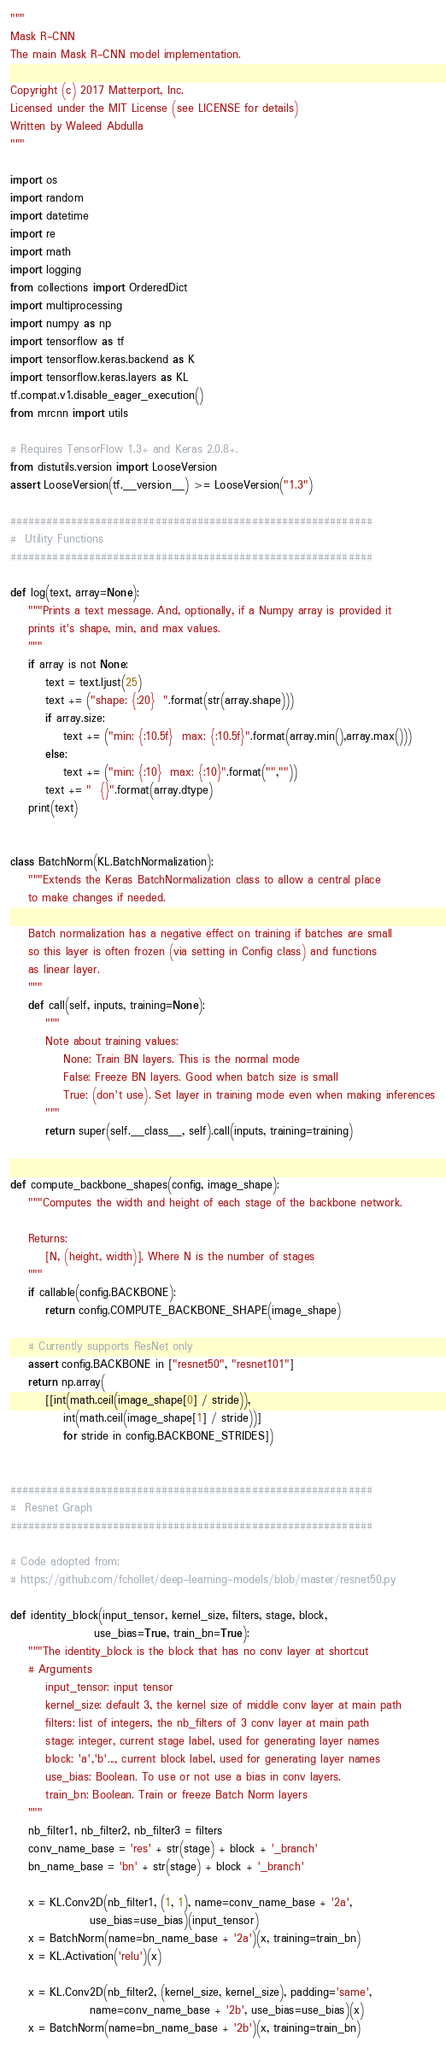Convert code to text. <code><loc_0><loc_0><loc_500><loc_500><_Python_>"""
Mask R-CNN
The main Mask R-CNN model implementation.

Copyright (c) 2017 Matterport, Inc.
Licensed under the MIT License (see LICENSE for details)
Written by Waleed Abdulla
"""

import os
import random
import datetime
import re
import math
import logging
from collections import OrderedDict
import multiprocessing
import numpy as np
import tensorflow as tf
import tensorflow.keras.backend as K
import tensorflow.keras.layers as KL
tf.compat.v1.disable_eager_execution()
from mrcnn import utils

# Requires TensorFlow 1.3+ and Keras 2.0.8+.
from distutils.version import LooseVersion
assert LooseVersion(tf.__version__) >= LooseVersion("1.3")

############################################################
#  Utility Functions
############################################################

def log(text, array=None):
    """Prints a text message. And, optionally, if a Numpy array is provided it
    prints it's shape, min, and max values.
    """
    if array is not None:
        text = text.ljust(25)
        text += ("shape: {:20}  ".format(str(array.shape)))
        if array.size:
            text += ("min: {:10.5f}  max: {:10.5f}".format(array.min(),array.max()))
        else:
            text += ("min: {:10}  max: {:10}".format("",""))
        text += "  {}".format(array.dtype)
    print(text)


class BatchNorm(KL.BatchNormalization):
    """Extends the Keras BatchNormalization class to allow a central place
    to make changes if needed.

    Batch normalization has a negative effect on training if batches are small
    so this layer is often frozen (via setting in Config class) and functions
    as linear layer.
    """
    def call(self, inputs, training=None):
        """
        Note about training values:
            None: Train BN layers. This is the normal mode
            False: Freeze BN layers. Good when batch size is small
            True: (don't use). Set layer in training mode even when making inferences
        """
        return super(self.__class__, self).call(inputs, training=training)


def compute_backbone_shapes(config, image_shape):
    """Computes the width and height of each stage of the backbone network.

    Returns:
        [N, (height, width)]. Where N is the number of stages
    """
    if callable(config.BACKBONE):
        return config.COMPUTE_BACKBONE_SHAPE(image_shape)

    # Currently supports ResNet only
    assert config.BACKBONE in ["resnet50", "resnet101"]
    return np.array(
        [[int(math.ceil(image_shape[0] / stride)),
            int(math.ceil(image_shape[1] / stride))]
            for stride in config.BACKBONE_STRIDES])


############################################################
#  Resnet Graph
############################################################

# Code adopted from:
# https://github.com/fchollet/deep-learning-models/blob/master/resnet50.py

def identity_block(input_tensor, kernel_size, filters, stage, block,
                   use_bias=True, train_bn=True):
    """The identity_block is the block that has no conv layer at shortcut
    # Arguments
        input_tensor: input tensor
        kernel_size: default 3, the kernel size of middle conv layer at main path
        filters: list of integers, the nb_filters of 3 conv layer at main path
        stage: integer, current stage label, used for generating layer names
        block: 'a','b'..., current block label, used for generating layer names
        use_bias: Boolean. To use or not use a bias in conv layers.
        train_bn: Boolean. Train or freeze Batch Norm layers
    """
    nb_filter1, nb_filter2, nb_filter3 = filters
    conv_name_base = 'res' + str(stage) + block + '_branch'
    bn_name_base = 'bn' + str(stage) + block + '_branch'

    x = KL.Conv2D(nb_filter1, (1, 1), name=conv_name_base + '2a',
                  use_bias=use_bias)(input_tensor)
    x = BatchNorm(name=bn_name_base + '2a')(x, training=train_bn)
    x = KL.Activation('relu')(x)

    x = KL.Conv2D(nb_filter2, (kernel_size, kernel_size), padding='same',
                  name=conv_name_base + '2b', use_bias=use_bias)(x)
    x = BatchNorm(name=bn_name_base + '2b')(x, training=train_bn)</code> 